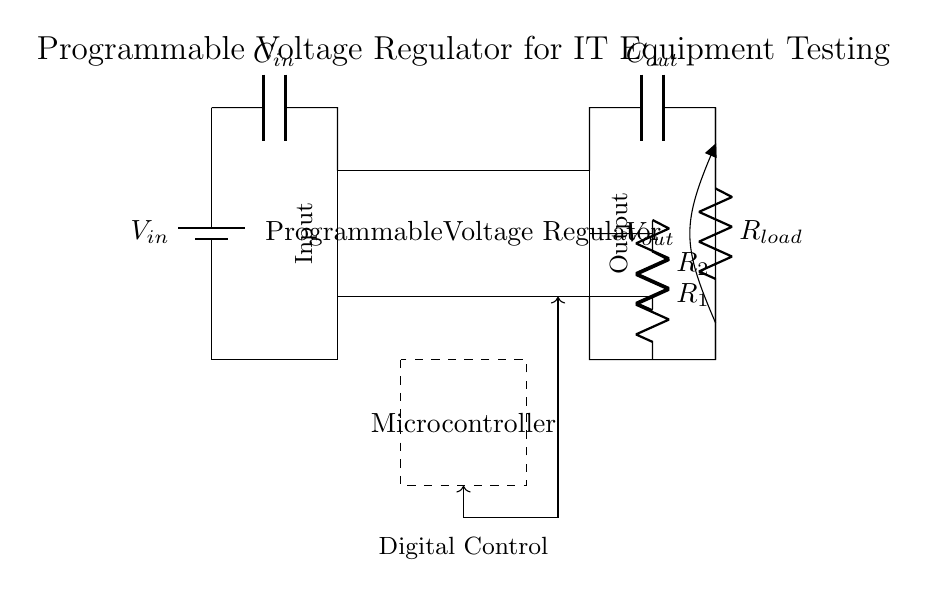What is the input component of the circuit? The input component is represented as a battery in the circuit diagram. A battery provides the necessary voltage for the circuit to operate.
Answer: Battery What is the function of the programmable voltage regulator? The programmable voltage regulator adjusts the output voltage to desired levels for testing various IT equipment. It can output different voltages based on the voltage divider configuration from the feedback network.
Answer: Voltage adjustment How many resistors are involved in the feedback network? There are two resistors, R1 and R2, in the feedback network, which are essential for setting the output voltage through the voltage divider method.
Answer: Two What type of control unit is shown in the circuit? A microcontroller is indicated in the circuit, allowing for digital control of the voltage regulator effectively through programming and feedback.
Answer: Microcontroller What is the purpose of the capacitors in this circuit? The capacitors, C_in and C_out, stabilize the input and output voltages, respectively, helping to filter out noise and ensuring smooth operation of the voltage regulator.
Answer: Voltage stabilization How does the load resistor affect the circuit? The load resistor, R_load, at the output determines the load current and affects the output voltage as the regulator must provide sufficient current to maintain the set voltage.
Answer: Current determination 